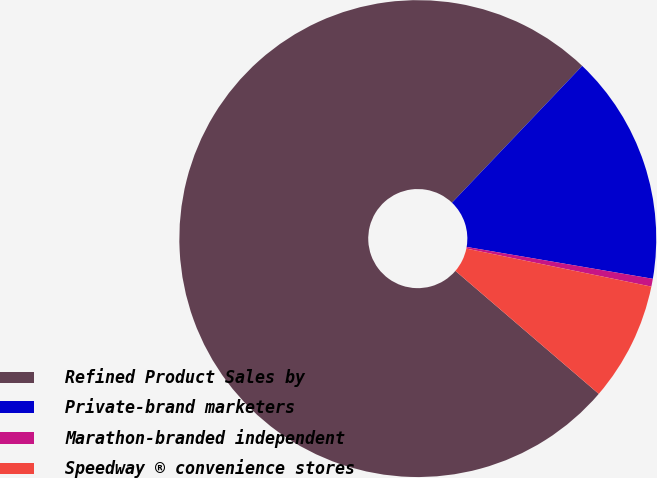<chart> <loc_0><loc_0><loc_500><loc_500><pie_chart><fcel>Refined Product Sales by<fcel>Private-brand marketers<fcel>Marathon-branded independent<fcel>Speedway ® convenience stores<nl><fcel>75.83%<fcel>15.59%<fcel>0.53%<fcel>8.06%<nl></chart> 